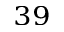<formula> <loc_0><loc_0><loc_500><loc_500>^ { 3 9 }</formula> 